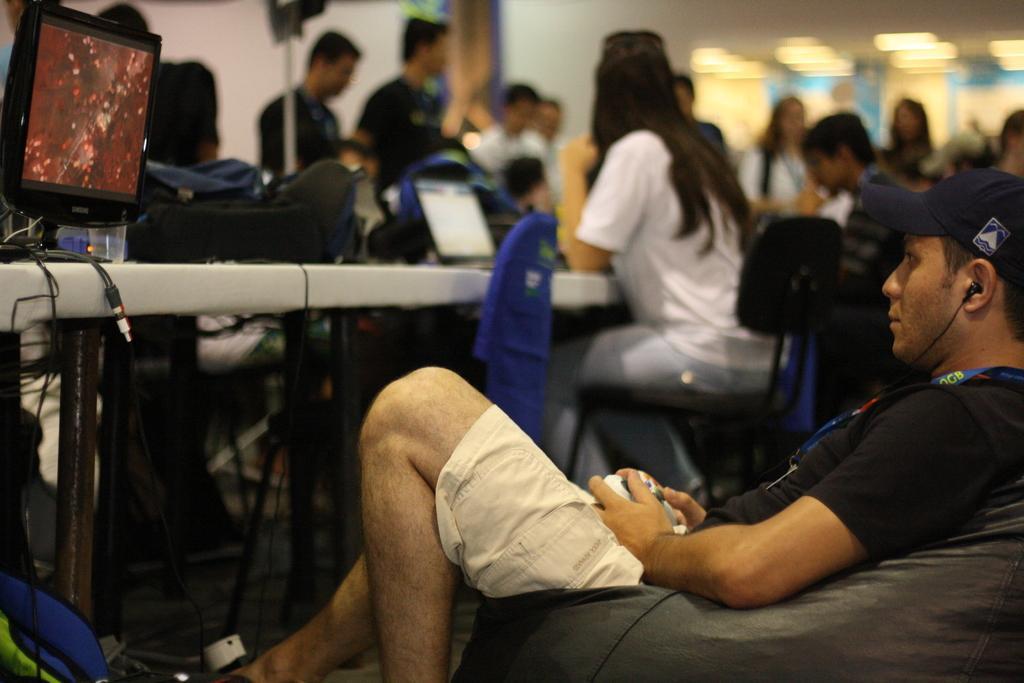How would you summarize this image in a sentence or two? This picture shows the inner view of a building, few people are standing, few people are sitting, one computer, some wires, one laptop on the table, some objects on the floor, some lights, some objects attached to the walls, some objects on the table, some chairs, one chair with blue cloth and the background is blurred. There is one man sitting on the bean bag, wearing earphones and holding one object. 